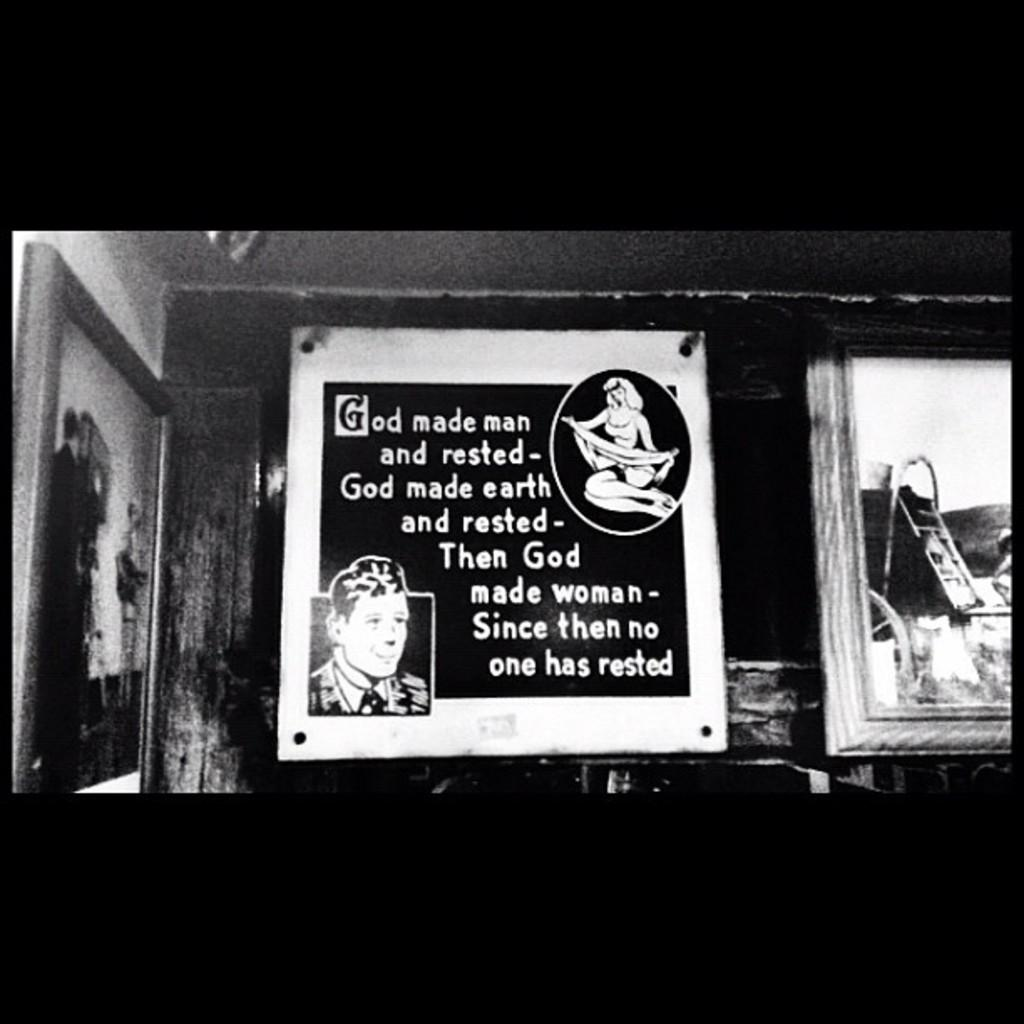<image>
Provide a brief description of the given image. A black and white picture captioned God made man.... 